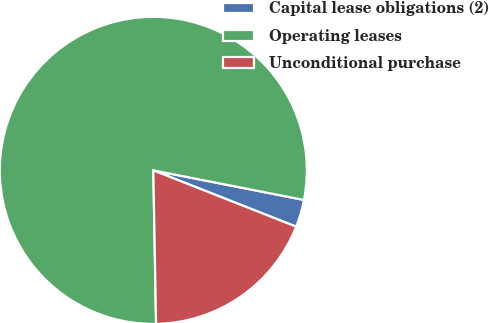Convert chart to OTSL. <chart><loc_0><loc_0><loc_500><loc_500><pie_chart><fcel>Capital lease obligations (2)<fcel>Operating leases<fcel>Unconditional purchase<nl><fcel>2.89%<fcel>78.37%<fcel>18.74%<nl></chart> 